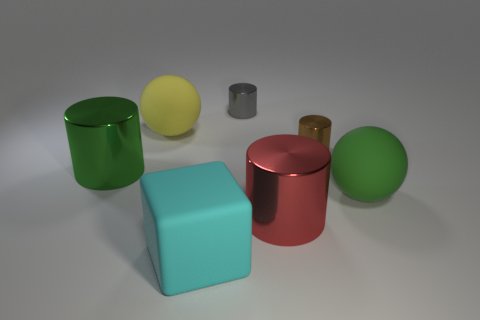Subtract all yellow cylinders. Subtract all cyan blocks. How many cylinders are left? 4 Add 1 red balls. How many objects exist? 8 Subtract all cylinders. How many objects are left? 3 Add 5 big purple matte cylinders. How many big purple matte cylinders exist? 5 Subtract 0 cyan cylinders. How many objects are left? 7 Subtract all big cyan things. Subtract all big cylinders. How many objects are left? 4 Add 7 red things. How many red things are left? 8 